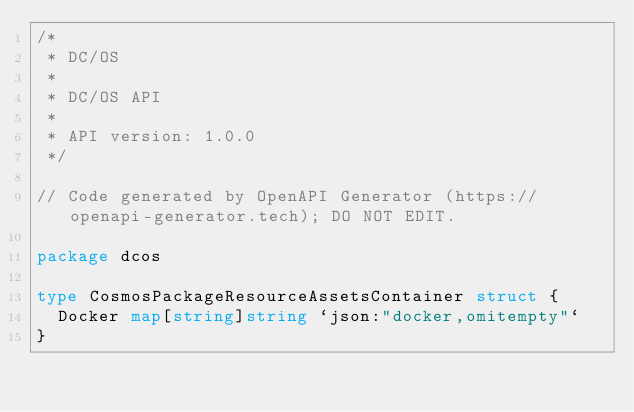Convert code to text. <code><loc_0><loc_0><loc_500><loc_500><_Go_>/*
 * DC/OS
 *
 * DC/OS API
 *
 * API version: 1.0.0
 */

// Code generated by OpenAPI Generator (https://openapi-generator.tech); DO NOT EDIT.

package dcos

type CosmosPackageResourceAssetsContainer struct {
	Docker map[string]string `json:"docker,omitempty"`
}
</code> 